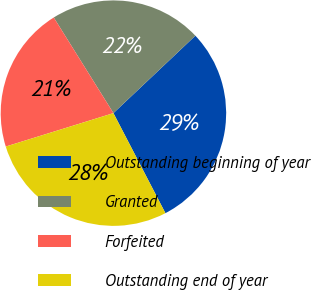Convert chart to OTSL. <chart><loc_0><loc_0><loc_500><loc_500><pie_chart><fcel>Outstanding beginning of year<fcel>Granted<fcel>Forfeited<fcel>Outstanding end of year<nl><fcel>29.42%<fcel>21.83%<fcel>20.91%<fcel>27.84%<nl></chart> 